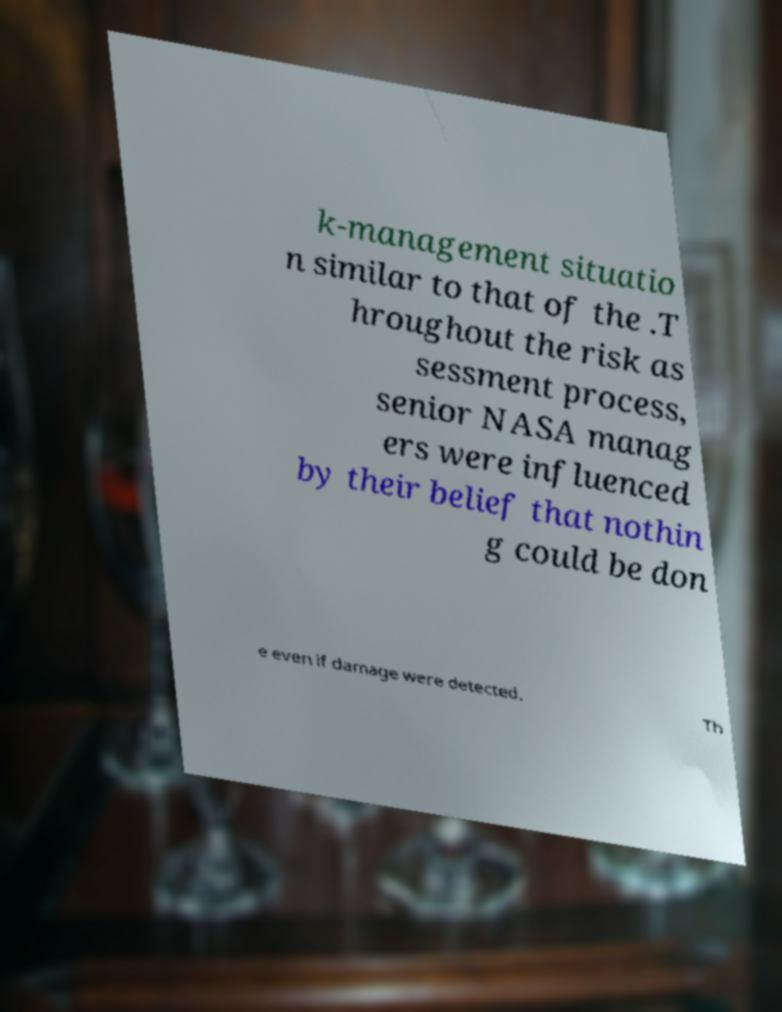What messages or text are displayed in this image? I need them in a readable, typed format. k-management situatio n similar to that of the .T hroughout the risk as sessment process, senior NASA manag ers were influenced by their belief that nothin g could be don e even if damage were detected. Th 